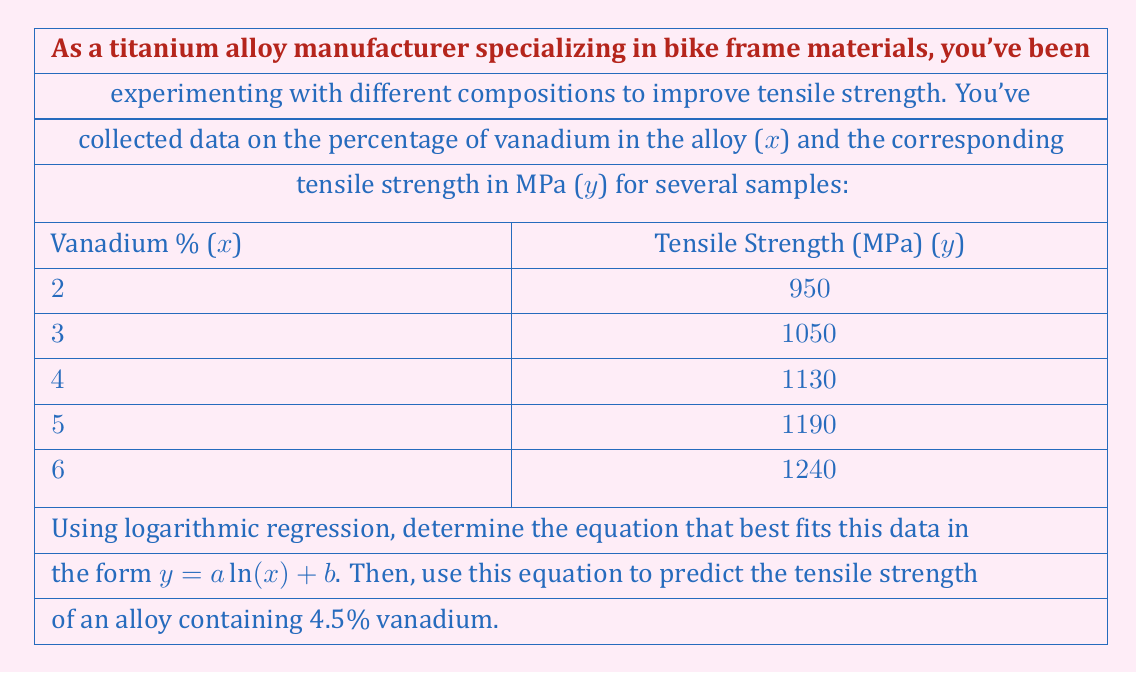Teach me how to tackle this problem. To solve this problem, we'll use logarithmic regression to find the equation $y = a \ln(x) + b$ that best fits the given data. Then, we'll use the resulting equation to predict the tensile strength for 4.5% vanadium.

Step 1: Transform the data for linear regression
Let $u = \ln(x)$ and $v = y$. This transforms the equation to $v = au + b$, which is linear.

| x | y    | u = ln(x) | v = y |
|---|------|-----------|-------|
| 2 | 950  | 0.6931    | 950   |
| 3 | 1050 | 1.0986    | 1050  |
| 4 | 1130 | 1.3863    | 1130  |
| 5 | 1190 | 1.6094    | 1190  |
| 6 | 1240 | 1.7918    | 1240  |

Step 2: Calculate required sums
$n = 5$
$\sum u = 6.5792$
$\sum v = 5560$
$\sum u^2 = 9.4146$
$\sum uv = 6857.0374$

Step 3: Use linear regression formulas to find a and b
$$a = \frac{n\sum uv - \sum u \sum v}{n\sum u^2 - (\sum u)^2} = \frac{5(6857.0374) - (6.5792)(5560)}{5(9.4146) - (6.5792)^2} = 300.4454$$

$$b = \frac{\sum v - a\sum u}{n} = \frac{5560 - 300.4454(6.5792)}{5} = 791.5728$$

Step 4: Write the logarithmic regression equation
$y = 300.4454 \ln(x) + 791.5728$

Step 5: Predict tensile strength for 4.5% vanadium
$y = 300.4454 \ln(4.5) + 791.5728 = 1162.9$ MPa
Answer: The logarithmic regression equation is $y = 300.4454 \ln(x) + 791.5728$, where x is the percentage of vanadium and y is the tensile strength in MPa. The predicted tensile strength for an alloy containing 4.5% vanadium is approximately 1162.9 MPa. 